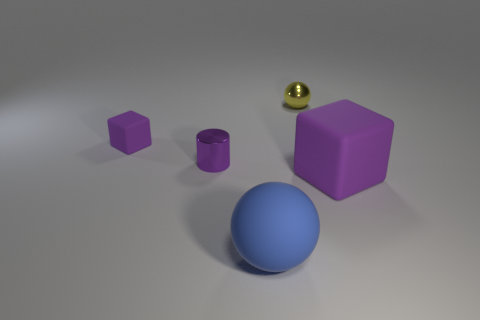Add 1 tiny gray metallic objects. How many objects exist? 6 Subtract all blue spheres. How many spheres are left? 1 Subtract all yellow cubes. How many blue spheres are left? 1 Subtract all small blue matte spheres. Subtract all big purple things. How many objects are left? 4 Add 3 tiny matte cubes. How many tiny matte cubes are left? 4 Add 5 tiny blue matte things. How many tiny blue matte things exist? 5 Subtract 1 purple cubes. How many objects are left? 4 Subtract all cylinders. How many objects are left? 4 Subtract 1 cylinders. How many cylinders are left? 0 Subtract all red blocks. Subtract all red spheres. How many blocks are left? 2 